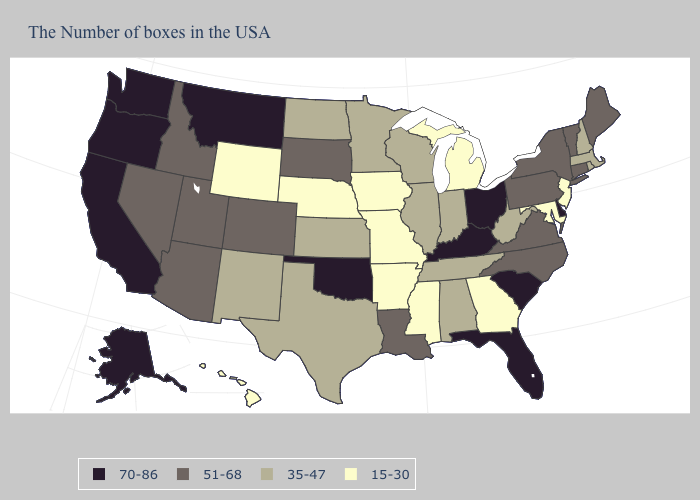Among the states that border South Dakota , which have the lowest value?
Short answer required. Iowa, Nebraska, Wyoming. Name the states that have a value in the range 70-86?
Write a very short answer. Delaware, South Carolina, Ohio, Florida, Kentucky, Oklahoma, Montana, California, Washington, Oregon, Alaska. Does Virginia have a higher value than Iowa?
Give a very brief answer. Yes. Among the states that border Nebraska , which have the lowest value?
Write a very short answer. Missouri, Iowa, Wyoming. Which states have the lowest value in the USA?
Be succinct. New Jersey, Maryland, Georgia, Michigan, Mississippi, Missouri, Arkansas, Iowa, Nebraska, Wyoming, Hawaii. Does Indiana have the same value as Wisconsin?
Give a very brief answer. Yes. Name the states that have a value in the range 35-47?
Give a very brief answer. Massachusetts, Rhode Island, New Hampshire, West Virginia, Indiana, Alabama, Tennessee, Wisconsin, Illinois, Minnesota, Kansas, Texas, North Dakota, New Mexico. What is the value of Georgia?
Write a very short answer. 15-30. Among the states that border New Jersey , which have the lowest value?
Quick response, please. New York, Pennsylvania. Does New Hampshire have the highest value in the USA?
Quick response, please. No. Which states have the highest value in the USA?
Keep it brief. Delaware, South Carolina, Ohio, Florida, Kentucky, Oklahoma, Montana, California, Washington, Oregon, Alaska. What is the value of Florida?
Short answer required. 70-86. What is the lowest value in the Northeast?
Write a very short answer. 15-30. Name the states that have a value in the range 51-68?
Short answer required. Maine, Vermont, Connecticut, New York, Pennsylvania, Virginia, North Carolina, Louisiana, South Dakota, Colorado, Utah, Arizona, Idaho, Nevada. Which states have the highest value in the USA?
Quick response, please. Delaware, South Carolina, Ohio, Florida, Kentucky, Oklahoma, Montana, California, Washington, Oregon, Alaska. 